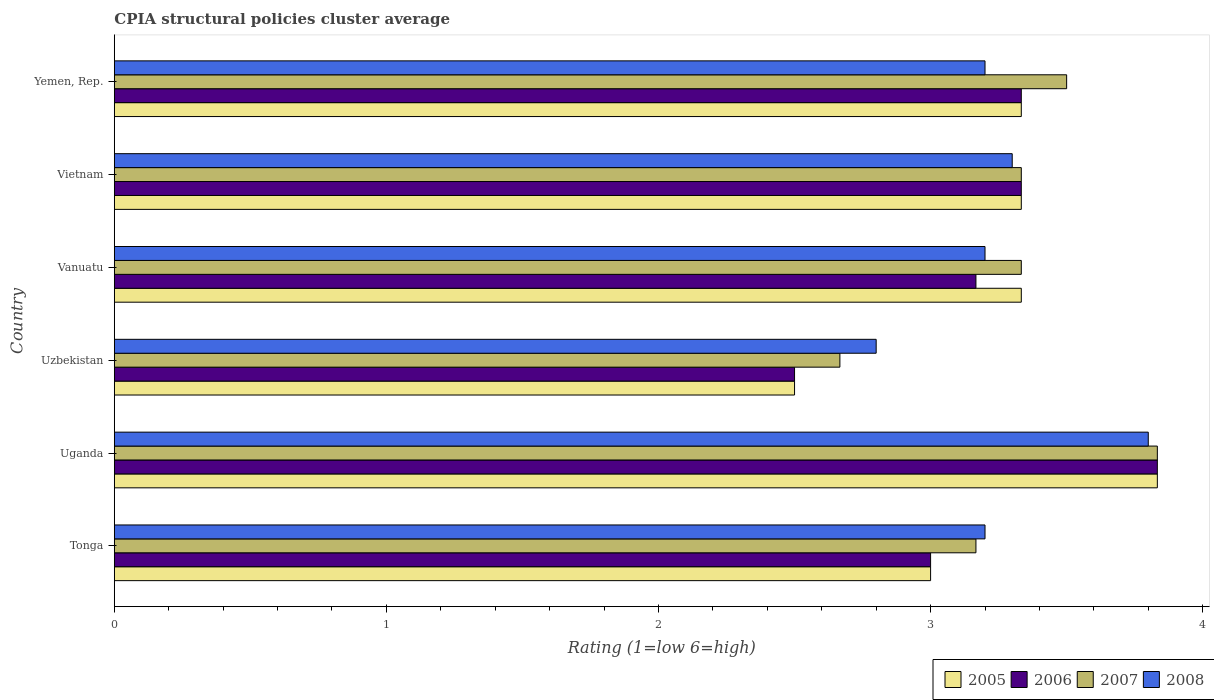How many bars are there on the 6th tick from the bottom?
Give a very brief answer. 4. What is the label of the 1st group of bars from the top?
Offer a terse response. Yemen, Rep. In how many cases, is the number of bars for a given country not equal to the number of legend labels?
Your answer should be compact. 0. What is the CPIA rating in 2006 in Uzbekistan?
Your response must be concise. 2.5. Across all countries, what is the minimum CPIA rating in 2006?
Make the answer very short. 2.5. In which country was the CPIA rating in 2008 maximum?
Ensure brevity in your answer.  Uganda. In which country was the CPIA rating in 2006 minimum?
Make the answer very short. Uzbekistan. What is the total CPIA rating in 2006 in the graph?
Offer a very short reply. 19.17. What is the difference between the CPIA rating in 2006 in Tonga and that in Vanuatu?
Your response must be concise. -0.17. What is the difference between the CPIA rating in 2005 in Uzbekistan and the CPIA rating in 2008 in Yemen, Rep.?
Your answer should be very brief. -0.7. What is the average CPIA rating in 2005 per country?
Offer a terse response. 3.22. What is the difference between the CPIA rating in 2006 and CPIA rating in 2008 in Vietnam?
Your answer should be very brief. 0.03. What is the ratio of the CPIA rating in 2005 in Vietnam to that in Yemen, Rep.?
Provide a succinct answer. 1. Is the difference between the CPIA rating in 2006 in Uganda and Yemen, Rep. greater than the difference between the CPIA rating in 2008 in Uganda and Yemen, Rep.?
Offer a terse response. No. What is the difference between the highest and the second highest CPIA rating in 2005?
Provide a short and direct response. 0.5. Is it the case that in every country, the sum of the CPIA rating in 2006 and CPIA rating in 2008 is greater than the sum of CPIA rating in 2005 and CPIA rating in 2007?
Give a very brief answer. No. Is it the case that in every country, the sum of the CPIA rating in 2008 and CPIA rating in 2005 is greater than the CPIA rating in 2007?
Your response must be concise. Yes. How many bars are there?
Keep it short and to the point. 24. Are all the bars in the graph horizontal?
Ensure brevity in your answer.  Yes. How many countries are there in the graph?
Provide a succinct answer. 6. What is the difference between two consecutive major ticks on the X-axis?
Provide a short and direct response. 1. Does the graph contain any zero values?
Your answer should be very brief. No. Where does the legend appear in the graph?
Provide a short and direct response. Bottom right. How many legend labels are there?
Provide a short and direct response. 4. What is the title of the graph?
Provide a succinct answer. CPIA structural policies cluster average. Does "1961" appear as one of the legend labels in the graph?
Provide a succinct answer. No. What is the label or title of the X-axis?
Ensure brevity in your answer.  Rating (1=low 6=high). What is the Rating (1=low 6=high) of 2005 in Tonga?
Your answer should be compact. 3. What is the Rating (1=low 6=high) in 2006 in Tonga?
Provide a succinct answer. 3. What is the Rating (1=low 6=high) of 2007 in Tonga?
Make the answer very short. 3.17. What is the Rating (1=low 6=high) in 2008 in Tonga?
Provide a succinct answer. 3.2. What is the Rating (1=low 6=high) in 2005 in Uganda?
Provide a succinct answer. 3.83. What is the Rating (1=low 6=high) of 2006 in Uganda?
Provide a short and direct response. 3.83. What is the Rating (1=low 6=high) in 2007 in Uganda?
Your answer should be very brief. 3.83. What is the Rating (1=low 6=high) in 2005 in Uzbekistan?
Your response must be concise. 2.5. What is the Rating (1=low 6=high) in 2007 in Uzbekistan?
Provide a short and direct response. 2.67. What is the Rating (1=low 6=high) of 2005 in Vanuatu?
Offer a terse response. 3.33. What is the Rating (1=low 6=high) in 2006 in Vanuatu?
Ensure brevity in your answer.  3.17. What is the Rating (1=low 6=high) in 2007 in Vanuatu?
Provide a succinct answer. 3.33. What is the Rating (1=low 6=high) of 2008 in Vanuatu?
Offer a terse response. 3.2. What is the Rating (1=low 6=high) of 2005 in Vietnam?
Your answer should be compact. 3.33. What is the Rating (1=low 6=high) in 2006 in Vietnam?
Give a very brief answer. 3.33. What is the Rating (1=low 6=high) in 2007 in Vietnam?
Your answer should be compact. 3.33. What is the Rating (1=low 6=high) in 2005 in Yemen, Rep.?
Your answer should be very brief. 3.33. What is the Rating (1=low 6=high) of 2006 in Yemen, Rep.?
Your answer should be very brief. 3.33. What is the Rating (1=low 6=high) in 2008 in Yemen, Rep.?
Keep it short and to the point. 3.2. Across all countries, what is the maximum Rating (1=low 6=high) in 2005?
Give a very brief answer. 3.83. Across all countries, what is the maximum Rating (1=low 6=high) of 2006?
Make the answer very short. 3.83. Across all countries, what is the maximum Rating (1=low 6=high) in 2007?
Provide a short and direct response. 3.83. Across all countries, what is the minimum Rating (1=low 6=high) in 2007?
Your answer should be very brief. 2.67. Across all countries, what is the minimum Rating (1=low 6=high) in 2008?
Give a very brief answer. 2.8. What is the total Rating (1=low 6=high) in 2005 in the graph?
Offer a very short reply. 19.33. What is the total Rating (1=low 6=high) in 2006 in the graph?
Give a very brief answer. 19.17. What is the total Rating (1=low 6=high) of 2007 in the graph?
Your answer should be compact. 19.83. What is the difference between the Rating (1=low 6=high) in 2005 in Tonga and that in Uganda?
Provide a short and direct response. -0.83. What is the difference between the Rating (1=low 6=high) of 2006 in Tonga and that in Uganda?
Your answer should be very brief. -0.83. What is the difference between the Rating (1=low 6=high) of 2005 in Tonga and that in Vanuatu?
Give a very brief answer. -0.33. What is the difference between the Rating (1=low 6=high) of 2006 in Tonga and that in Vanuatu?
Provide a succinct answer. -0.17. What is the difference between the Rating (1=low 6=high) in 2008 in Tonga and that in Vietnam?
Offer a very short reply. -0.1. What is the difference between the Rating (1=low 6=high) of 2006 in Uganda and that in Uzbekistan?
Offer a very short reply. 1.33. What is the difference between the Rating (1=low 6=high) of 2005 in Uganda and that in Vanuatu?
Give a very brief answer. 0.5. What is the difference between the Rating (1=low 6=high) in 2007 in Uganda and that in Vanuatu?
Offer a terse response. 0.5. What is the difference between the Rating (1=low 6=high) of 2008 in Uganda and that in Vanuatu?
Offer a terse response. 0.6. What is the difference between the Rating (1=low 6=high) of 2005 in Uganda and that in Vietnam?
Your response must be concise. 0.5. What is the difference between the Rating (1=low 6=high) of 2008 in Uganda and that in Vietnam?
Offer a very short reply. 0.5. What is the difference between the Rating (1=low 6=high) of 2005 in Uganda and that in Yemen, Rep.?
Keep it short and to the point. 0.5. What is the difference between the Rating (1=low 6=high) in 2005 in Uzbekistan and that in Vanuatu?
Make the answer very short. -0.83. What is the difference between the Rating (1=low 6=high) of 2008 in Uzbekistan and that in Vanuatu?
Provide a succinct answer. -0.4. What is the difference between the Rating (1=low 6=high) of 2006 in Vanuatu and that in Vietnam?
Your answer should be very brief. -0.17. What is the difference between the Rating (1=low 6=high) of 2007 in Vanuatu and that in Vietnam?
Offer a very short reply. 0. What is the difference between the Rating (1=low 6=high) of 2006 in Vanuatu and that in Yemen, Rep.?
Give a very brief answer. -0.17. What is the difference between the Rating (1=low 6=high) of 2007 in Vanuatu and that in Yemen, Rep.?
Your answer should be very brief. -0.17. What is the difference between the Rating (1=low 6=high) of 2005 in Vietnam and that in Yemen, Rep.?
Ensure brevity in your answer.  0. What is the difference between the Rating (1=low 6=high) in 2008 in Vietnam and that in Yemen, Rep.?
Keep it short and to the point. 0.1. What is the difference between the Rating (1=low 6=high) in 2005 in Tonga and the Rating (1=low 6=high) in 2006 in Uganda?
Your answer should be very brief. -0.83. What is the difference between the Rating (1=low 6=high) of 2006 in Tonga and the Rating (1=low 6=high) of 2008 in Uganda?
Keep it short and to the point. -0.8. What is the difference between the Rating (1=low 6=high) of 2007 in Tonga and the Rating (1=low 6=high) of 2008 in Uganda?
Provide a succinct answer. -0.63. What is the difference between the Rating (1=low 6=high) in 2005 in Tonga and the Rating (1=low 6=high) in 2007 in Uzbekistan?
Offer a terse response. 0.33. What is the difference between the Rating (1=low 6=high) in 2006 in Tonga and the Rating (1=low 6=high) in 2007 in Uzbekistan?
Keep it short and to the point. 0.33. What is the difference between the Rating (1=low 6=high) of 2006 in Tonga and the Rating (1=low 6=high) of 2008 in Uzbekistan?
Provide a short and direct response. 0.2. What is the difference between the Rating (1=low 6=high) of 2007 in Tonga and the Rating (1=low 6=high) of 2008 in Uzbekistan?
Ensure brevity in your answer.  0.37. What is the difference between the Rating (1=low 6=high) in 2005 in Tonga and the Rating (1=low 6=high) in 2007 in Vanuatu?
Make the answer very short. -0.33. What is the difference between the Rating (1=low 6=high) in 2005 in Tonga and the Rating (1=low 6=high) in 2008 in Vanuatu?
Keep it short and to the point. -0.2. What is the difference between the Rating (1=low 6=high) of 2006 in Tonga and the Rating (1=low 6=high) of 2008 in Vanuatu?
Give a very brief answer. -0.2. What is the difference between the Rating (1=low 6=high) in 2007 in Tonga and the Rating (1=low 6=high) in 2008 in Vanuatu?
Your response must be concise. -0.03. What is the difference between the Rating (1=low 6=high) of 2005 in Tonga and the Rating (1=low 6=high) of 2007 in Vietnam?
Your answer should be compact. -0.33. What is the difference between the Rating (1=low 6=high) of 2006 in Tonga and the Rating (1=low 6=high) of 2008 in Vietnam?
Keep it short and to the point. -0.3. What is the difference between the Rating (1=low 6=high) in 2007 in Tonga and the Rating (1=low 6=high) in 2008 in Vietnam?
Provide a succinct answer. -0.13. What is the difference between the Rating (1=low 6=high) of 2006 in Tonga and the Rating (1=low 6=high) of 2007 in Yemen, Rep.?
Ensure brevity in your answer.  -0.5. What is the difference between the Rating (1=low 6=high) of 2006 in Tonga and the Rating (1=low 6=high) of 2008 in Yemen, Rep.?
Give a very brief answer. -0.2. What is the difference between the Rating (1=low 6=high) of 2007 in Tonga and the Rating (1=low 6=high) of 2008 in Yemen, Rep.?
Your answer should be compact. -0.03. What is the difference between the Rating (1=low 6=high) of 2005 in Uganda and the Rating (1=low 6=high) of 2006 in Uzbekistan?
Offer a terse response. 1.33. What is the difference between the Rating (1=low 6=high) of 2005 in Uganda and the Rating (1=low 6=high) of 2007 in Uzbekistan?
Keep it short and to the point. 1.17. What is the difference between the Rating (1=low 6=high) in 2005 in Uganda and the Rating (1=low 6=high) in 2008 in Uzbekistan?
Ensure brevity in your answer.  1.03. What is the difference between the Rating (1=low 6=high) of 2006 in Uganda and the Rating (1=low 6=high) of 2008 in Uzbekistan?
Provide a short and direct response. 1.03. What is the difference between the Rating (1=low 6=high) in 2005 in Uganda and the Rating (1=low 6=high) in 2007 in Vanuatu?
Your answer should be very brief. 0.5. What is the difference between the Rating (1=low 6=high) of 2005 in Uganda and the Rating (1=low 6=high) of 2008 in Vanuatu?
Provide a succinct answer. 0.63. What is the difference between the Rating (1=low 6=high) in 2006 in Uganda and the Rating (1=low 6=high) in 2008 in Vanuatu?
Your answer should be compact. 0.63. What is the difference between the Rating (1=low 6=high) in 2007 in Uganda and the Rating (1=low 6=high) in 2008 in Vanuatu?
Provide a short and direct response. 0.63. What is the difference between the Rating (1=low 6=high) of 2005 in Uganda and the Rating (1=low 6=high) of 2006 in Vietnam?
Your response must be concise. 0.5. What is the difference between the Rating (1=low 6=high) of 2005 in Uganda and the Rating (1=low 6=high) of 2007 in Vietnam?
Provide a short and direct response. 0.5. What is the difference between the Rating (1=low 6=high) of 2005 in Uganda and the Rating (1=low 6=high) of 2008 in Vietnam?
Your answer should be compact. 0.53. What is the difference between the Rating (1=low 6=high) of 2006 in Uganda and the Rating (1=low 6=high) of 2008 in Vietnam?
Offer a very short reply. 0.53. What is the difference between the Rating (1=low 6=high) of 2007 in Uganda and the Rating (1=low 6=high) of 2008 in Vietnam?
Offer a very short reply. 0.53. What is the difference between the Rating (1=low 6=high) in 2005 in Uganda and the Rating (1=low 6=high) in 2007 in Yemen, Rep.?
Your response must be concise. 0.33. What is the difference between the Rating (1=low 6=high) in 2005 in Uganda and the Rating (1=low 6=high) in 2008 in Yemen, Rep.?
Your answer should be very brief. 0.63. What is the difference between the Rating (1=low 6=high) of 2006 in Uganda and the Rating (1=low 6=high) of 2007 in Yemen, Rep.?
Provide a short and direct response. 0.33. What is the difference between the Rating (1=low 6=high) of 2006 in Uganda and the Rating (1=low 6=high) of 2008 in Yemen, Rep.?
Your answer should be very brief. 0.63. What is the difference between the Rating (1=low 6=high) in 2007 in Uganda and the Rating (1=low 6=high) in 2008 in Yemen, Rep.?
Make the answer very short. 0.63. What is the difference between the Rating (1=low 6=high) of 2005 in Uzbekistan and the Rating (1=low 6=high) of 2007 in Vanuatu?
Your response must be concise. -0.83. What is the difference between the Rating (1=low 6=high) in 2005 in Uzbekistan and the Rating (1=low 6=high) in 2008 in Vanuatu?
Your answer should be very brief. -0.7. What is the difference between the Rating (1=low 6=high) of 2006 in Uzbekistan and the Rating (1=low 6=high) of 2007 in Vanuatu?
Make the answer very short. -0.83. What is the difference between the Rating (1=low 6=high) in 2006 in Uzbekistan and the Rating (1=low 6=high) in 2008 in Vanuatu?
Ensure brevity in your answer.  -0.7. What is the difference between the Rating (1=low 6=high) in 2007 in Uzbekistan and the Rating (1=low 6=high) in 2008 in Vanuatu?
Ensure brevity in your answer.  -0.53. What is the difference between the Rating (1=low 6=high) in 2005 in Uzbekistan and the Rating (1=low 6=high) in 2006 in Vietnam?
Offer a terse response. -0.83. What is the difference between the Rating (1=low 6=high) of 2005 in Uzbekistan and the Rating (1=low 6=high) of 2008 in Vietnam?
Provide a short and direct response. -0.8. What is the difference between the Rating (1=low 6=high) of 2006 in Uzbekistan and the Rating (1=low 6=high) of 2007 in Vietnam?
Offer a terse response. -0.83. What is the difference between the Rating (1=low 6=high) of 2007 in Uzbekistan and the Rating (1=low 6=high) of 2008 in Vietnam?
Offer a very short reply. -0.63. What is the difference between the Rating (1=low 6=high) of 2005 in Uzbekistan and the Rating (1=low 6=high) of 2006 in Yemen, Rep.?
Offer a terse response. -0.83. What is the difference between the Rating (1=low 6=high) of 2006 in Uzbekistan and the Rating (1=low 6=high) of 2007 in Yemen, Rep.?
Your response must be concise. -1. What is the difference between the Rating (1=low 6=high) of 2007 in Uzbekistan and the Rating (1=low 6=high) of 2008 in Yemen, Rep.?
Give a very brief answer. -0.53. What is the difference between the Rating (1=low 6=high) in 2005 in Vanuatu and the Rating (1=low 6=high) in 2006 in Vietnam?
Ensure brevity in your answer.  0. What is the difference between the Rating (1=low 6=high) of 2005 in Vanuatu and the Rating (1=low 6=high) of 2007 in Vietnam?
Your answer should be very brief. 0. What is the difference between the Rating (1=low 6=high) in 2005 in Vanuatu and the Rating (1=low 6=high) in 2008 in Vietnam?
Your response must be concise. 0.03. What is the difference between the Rating (1=low 6=high) of 2006 in Vanuatu and the Rating (1=low 6=high) of 2008 in Vietnam?
Keep it short and to the point. -0.13. What is the difference between the Rating (1=low 6=high) in 2005 in Vanuatu and the Rating (1=low 6=high) in 2008 in Yemen, Rep.?
Your answer should be very brief. 0.13. What is the difference between the Rating (1=low 6=high) of 2006 in Vanuatu and the Rating (1=low 6=high) of 2008 in Yemen, Rep.?
Give a very brief answer. -0.03. What is the difference between the Rating (1=low 6=high) of 2007 in Vanuatu and the Rating (1=low 6=high) of 2008 in Yemen, Rep.?
Provide a succinct answer. 0.13. What is the difference between the Rating (1=low 6=high) in 2005 in Vietnam and the Rating (1=low 6=high) in 2006 in Yemen, Rep.?
Provide a short and direct response. 0. What is the difference between the Rating (1=low 6=high) of 2005 in Vietnam and the Rating (1=low 6=high) of 2008 in Yemen, Rep.?
Your answer should be compact. 0.13. What is the difference between the Rating (1=low 6=high) in 2006 in Vietnam and the Rating (1=low 6=high) in 2007 in Yemen, Rep.?
Your answer should be very brief. -0.17. What is the difference between the Rating (1=low 6=high) of 2006 in Vietnam and the Rating (1=low 6=high) of 2008 in Yemen, Rep.?
Make the answer very short. 0.13. What is the difference between the Rating (1=low 6=high) in 2007 in Vietnam and the Rating (1=low 6=high) in 2008 in Yemen, Rep.?
Your response must be concise. 0.13. What is the average Rating (1=low 6=high) of 2005 per country?
Offer a very short reply. 3.22. What is the average Rating (1=low 6=high) of 2006 per country?
Ensure brevity in your answer.  3.19. What is the average Rating (1=low 6=high) of 2007 per country?
Your response must be concise. 3.31. What is the average Rating (1=low 6=high) of 2008 per country?
Keep it short and to the point. 3.25. What is the difference between the Rating (1=low 6=high) of 2005 and Rating (1=low 6=high) of 2006 in Tonga?
Your answer should be compact. 0. What is the difference between the Rating (1=low 6=high) of 2005 and Rating (1=low 6=high) of 2007 in Tonga?
Give a very brief answer. -0.17. What is the difference between the Rating (1=low 6=high) of 2005 and Rating (1=low 6=high) of 2008 in Tonga?
Give a very brief answer. -0.2. What is the difference between the Rating (1=low 6=high) in 2006 and Rating (1=low 6=high) in 2008 in Tonga?
Provide a short and direct response. -0.2. What is the difference between the Rating (1=low 6=high) in 2007 and Rating (1=low 6=high) in 2008 in Tonga?
Give a very brief answer. -0.03. What is the difference between the Rating (1=low 6=high) in 2006 and Rating (1=low 6=high) in 2007 in Uganda?
Ensure brevity in your answer.  0. What is the difference between the Rating (1=low 6=high) in 2005 and Rating (1=low 6=high) in 2007 in Uzbekistan?
Your answer should be compact. -0.17. What is the difference between the Rating (1=low 6=high) of 2005 and Rating (1=low 6=high) of 2008 in Uzbekistan?
Offer a very short reply. -0.3. What is the difference between the Rating (1=low 6=high) in 2006 and Rating (1=low 6=high) in 2008 in Uzbekistan?
Offer a very short reply. -0.3. What is the difference between the Rating (1=low 6=high) of 2007 and Rating (1=low 6=high) of 2008 in Uzbekistan?
Make the answer very short. -0.13. What is the difference between the Rating (1=low 6=high) in 2005 and Rating (1=low 6=high) in 2006 in Vanuatu?
Your answer should be very brief. 0.17. What is the difference between the Rating (1=low 6=high) in 2005 and Rating (1=low 6=high) in 2008 in Vanuatu?
Provide a short and direct response. 0.13. What is the difference between the Rating (1=low 6=high) of 2006 and Rating (1=low 6=high) of 2008 in Vanuatu?
Your answer should be very brief. -0.03. What is the difference between the Rating (1=low 6=high) of 2007 and Rating (1=low 6=high) of 2008 in Vanuatu?
Make the answer very short. 0.13. What is the difference between the Rating (1=low 6=high) in 2005 and Rating (1=low 6=high) in 2007 in Vietnam?
Provide a succinct answer. 0. What is the difference between the Rating (1=low 6=high) in 2005 and Rating (1=low 6=high) in 2007 in Yemen, Rep.?
Offer a terse response. -0.17. What is the difference between the Rating (1=low 6=high) of 2005 and Rating (1=low 6=high) of 2008 in Yemen, Rep.?
Your answer should be very brief. 0.13. What is the difference between the Rating (1=low 6=high) in 2006 and Rating (1=low 6=high) in 2008 in Yemen, Rep.?
Offer a terse response. 0.13. What is the ratio of the Rating (1=low 6=high) of 2005 in Tonga to that in Uganda?
Ensure brevity in your answer.  0.78. What is the ratio of the Rating (1=low 6=high) in 2006 in Tonga to that in Uganda?
Offer a very short reply. 0.78. What is the ratio of the Rating (1=low 6=high) of 2007 in Tonga to that in Uganda?
Give a very brief answer. 0.83. What is the ratio of the Rating (1=low 6=high) in 2008 in Tonga to that in Uganda?
Give a very brief answer. 0.84. What is the ratio of the Rating (1=low 6=high) of 2006 in Tonga to that in Uzbekistan?
Keep it short and to the point. 1.2. What is the ratio of the Rating (1=low 6=high) in 2007 in Tonga to that in Uzbekistan?
Your response must be concise. 1.19. What is the ratio of the Rating (1=low 6=high) in 2008 in Tonga to that in Uzbekistan?
Make the answer very short. 1.14. What is the ratio of the Rating (1=low 6=high) in 2007 in Tonga to that in Vanuatu?
Your answer should be very brief. 0.95. What is the ratio of the Rating (1=low 6=high) of 2008 in Tonga to that in Vanuatu?
Offer a terse response. 1. What is the ratio of the Rating (1=low 6=high) of 2005 in Tonga to that in Vietnam?
Your response must be concise. 0.9. What is the ratio of the Rating (1=low 6=high) of 2006 in Tonga to that in Vietnam?
Offer a terse response. 0.9. What is the ratio of the Rating (1=low 6=high) in 2007 in Tonga to that in Vietnam?
Offer a terse response. 0.95. What is the ratio of the Rating (1=low 6=high) in 2008 in Tonga to that in Vietnam?
Provide a succinct answer. 0.97. What is the ratio of the Rating (1=low 6=high) in 2007 in Tonga to that in Yemen, Rep.?
Provide a short and direct response. 0.9. What is the ratio of the Rating (1=low 6=high) in 2005 in Uganda to that in Uzbekistan?
Your answer should be very brief. 1.53. What is the ratio of the Rating (1=low 6=high) of 2006 in Uganda to that in Uzbekistan?
Provide a short and direct response. 1.53. What is the ratio of the Rating (1=low 6=high) in 2007 in Uganda to that in Uzbekistan?
Make the answer very short. 1.44. What is the ratio of the Rating (1=low 6=high) in 2008 in Uganda to that in Uzbekistan?
Your answer should be very brief. 1.36. What is the ratio of the Rating (1=low 6=high) of 2005 in Uganda to that in Vanuatu?
Offer a terse response. 1.15. What is the ratio of the Rating (1=low 6=high) in 2006 in Uganda to that in Vanuatu?
Provide a succinct answer. 1.21. What is the ratio of the Rating (1=low 6=high) in 2007 in Uganda to that in Vanuatu?
Keep it short and to the point. 1.15. What is the ratio of the Rating (1=low 6=high) in 2008 in Uganda to that in Vanuatu?
Keep it short and to the point. 1.19. What is the ratio of the Rating (1=low 6=high) of 2005 in Uganda to that in Vietnam?
Provide a short and direct response. 1.15. What is the ratio of the Rating (1=low 6=high) of 2006 in Uganda to that in Vietnam?
Provide a short and direct response. 1.15. What is the ratio of the Rating (1=low 6=high) of 2007 in Uganda to that in Vietnam?
Offer a terse response. 1.15. What is the ratio of the Rating (1=low 6=high) of 2008 in Uganda to that in Vietnam?
Give a very brief answer. 1.15. What is the ratio of the Rating (1=low 6=high) of 2005 in Uganda to that in Yemen, Rep.?
Ensure brevity in your answer.  1.15. What is the ratio of the Rating (1=low 6=high) in 2006 in Uganda to that in Yemen, Rep.?
Your answer should be compact. 1.15. What is the ratio of the Rating (1=low 6=high) in 2007 in Uganda to that in Yemen, Rep.?
Give a very brief answer. 1.1. What is the ratio of the Rating (1=low 6=high) in 2008 in Uganda to that in Yemen, Rep.?
Offer a very short reply. 1.19. What is the ratio of the Rating (1=low 6=high) of 2005 in Uzbekistan to that in Vanuatu?
Make the answer very short. 0.75. What is the ratio of the Rating (1=low 6=high) of 2006 in Uzbekistan to that in Vanuatu?
Your answer should be compact. 0.79. What is the ratio of the Rating (1=low 6=high) in 2007 in Uzbekistan to that in Vanuatu?
Offer a terse response. 0.8. What is the ratio of the Rating (1=low 6=high) of 2006 in Uzbekistan to that in Vietnam?
Provide a short and direct response. 0.75. What is the ratio of the Rating (1=low 6=high) of 2008 in Uzbekistan to that in Vietnam?
Ensure brevity in your answer.  0.85. What is the ratio of the Rating (1=low 6=high) of 2005 in Uzbekistan to that in Yemen, Rep.?
Offer a terse response. 0.75. What is the ratio of the Rating (1=low 6=high) of 2007 in Uzbekistan to that in Yemen, Rep.?
Make the answer very short. 0.76. What is the ratio of the Rating (1=low 6=high) in 2008 in Uzbekistan to that in Yemen, Rep.?
Your response must be concise. 0.88. What is the ratio of the Rating (1=low 6=high) in 2007 in Vanuatu to that in Vietnam?
Your answer should be very brief. 1. What is the ratio of the Rating (1=low 6=high) in 2008 in Vanuatu to that in Vietnam?
Your answer should be very brief. 0.97. What is the ratio of the Rating (1=low 6=high) in 2006 in Vanuatu to that in Yemen, Rep.?
Provide a short and direct response. 0.95. What is the ratio of the Rating (1=low 6=high) in 2008 in Vanuatu to that in Yemen, Rep.?
Give a very brief answer. 1. What is the ratio of the Rating (1=low 6=high) in 2006 in Vietnam to that in Yemen, Rep.?
Offer a terse response. 1. What is the ratio of the Rating (1=low 6=high) in 2008 in Vietnam to that in Yemen, Rep.?
Offer a very short reply. 1.03. What is the difference between the highest and the second highest Rating (1=low 6=high) of 2006?
Your answer should be compact. 0.5. What is the difference between the highest and the second highest Rating (1=low 6=high) of 2007?
Ensure brevity in your answer.  0.33. What is the difference between the highest and the lowest Rating (1=low 6=high) of 2005?
Make the answer very short. 1.33. What is the difference between the highest and the lowest Rating (1=low 6=high) of 2006?
Keep it short and to the point. 1.33. What is the difference between the highest and the lowest Rating (1=low 6=high) of 2008?
Your answer should be compact. 1. 